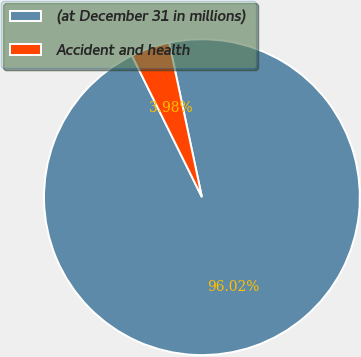Convert chart to OTSL. <chart><loc_0><loc_0><loc_500><loc_500><pie_chart><fcel>(at December 31 in millions)<fcel>Accident and health<nl><fcel>96.02%<fcel>3.98%<nl></chart> 